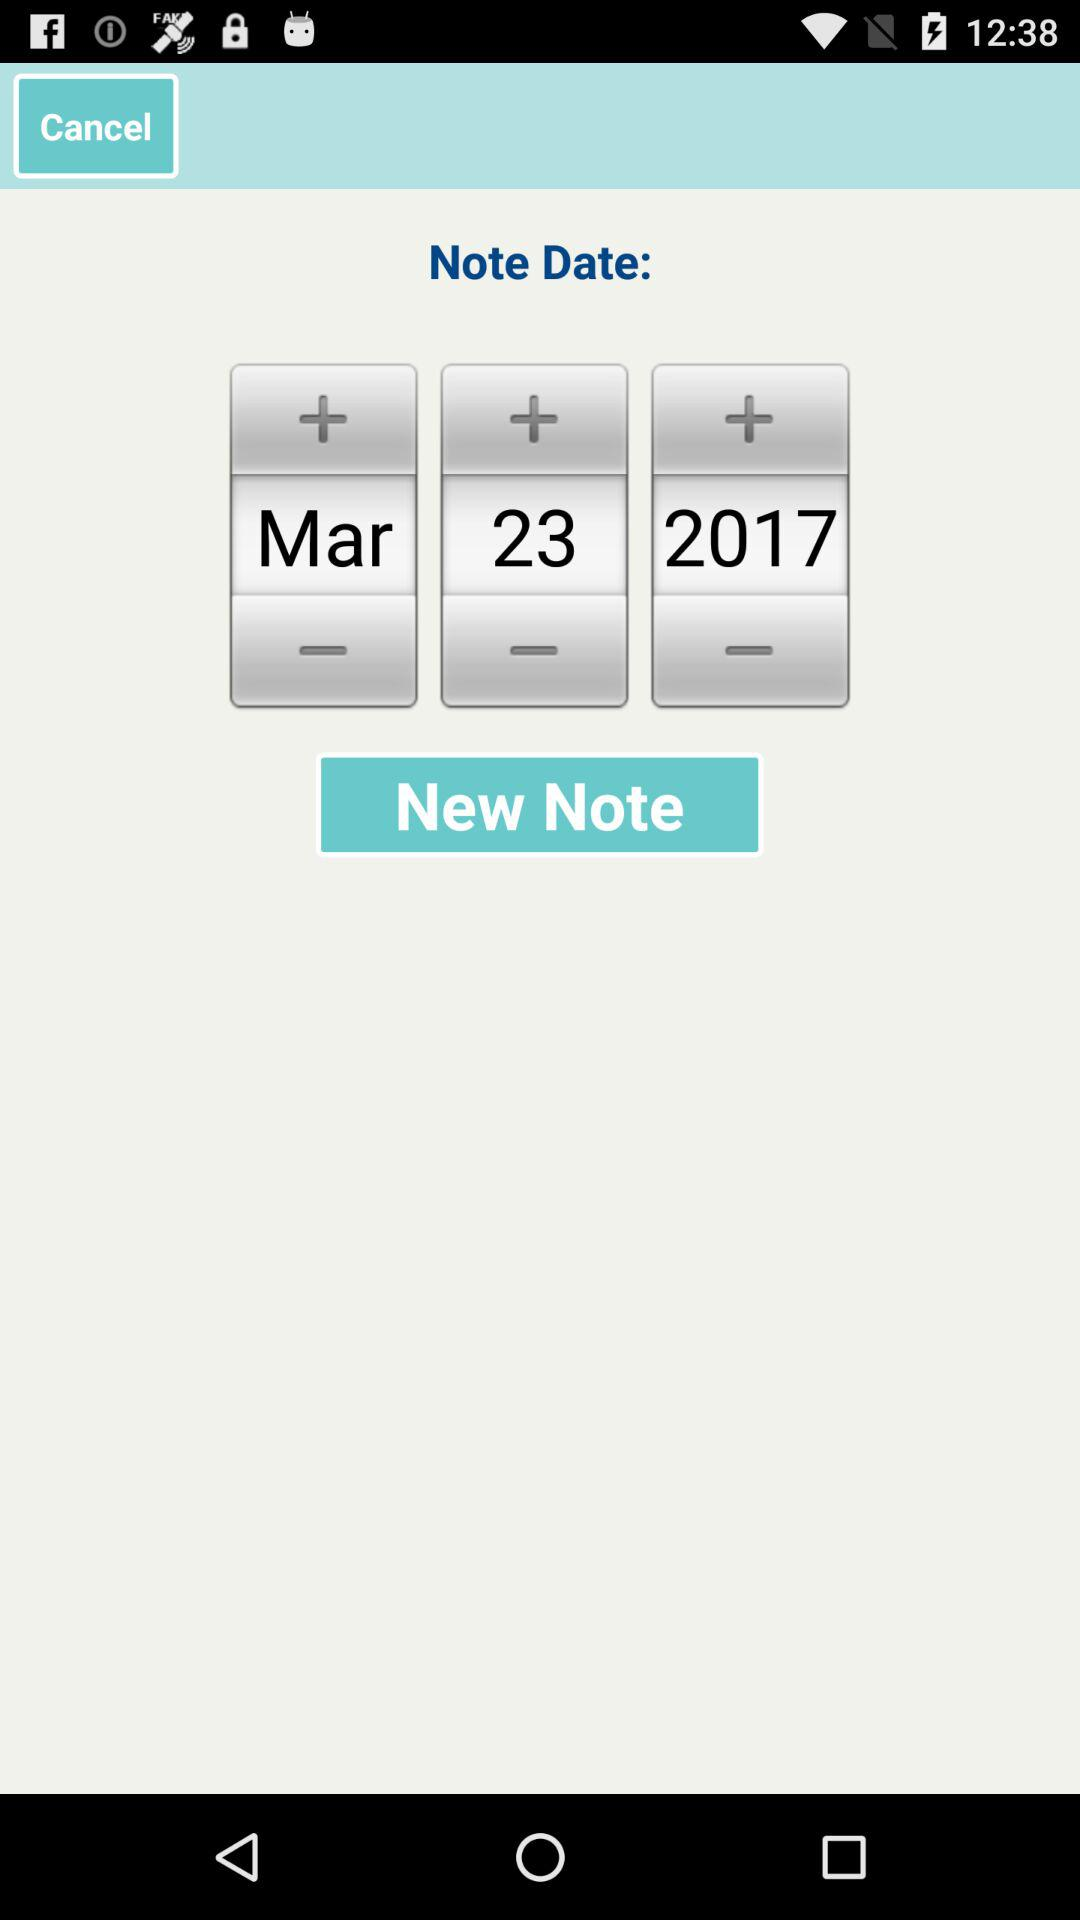What date was selected? The selected date was March 23, 2017. 